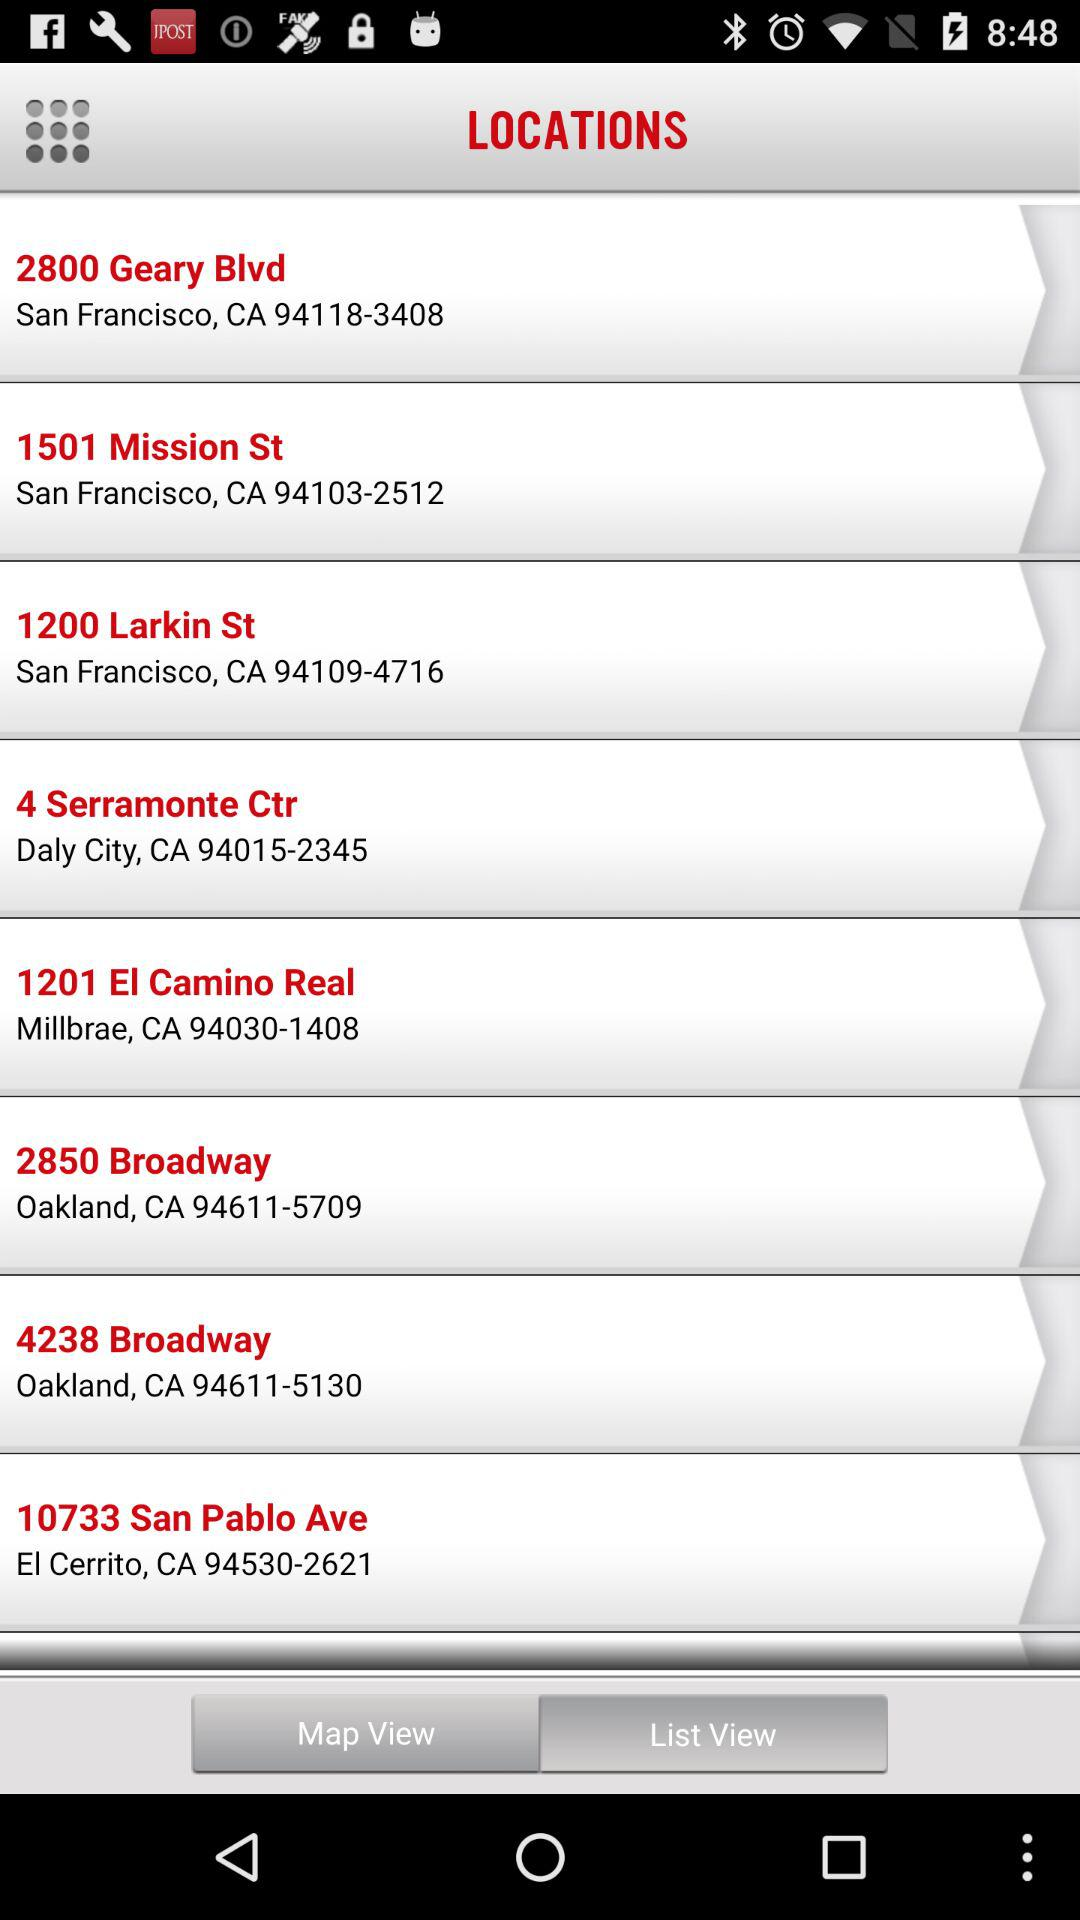What is the location of 2800 Geary Blvd? The location of 2800 Geary Blvd is San Francisco, CA 94118-3408. 